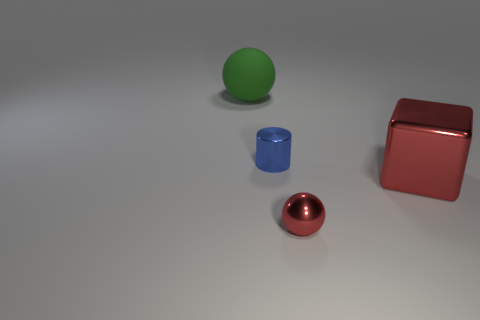Add 2 big red cubes. How many objects exist? 6 Subtract all cylinders. How many objects are left? 3 Add 1 big red metal cubes. How many big red metal cubes are left? 2 Add 4 tiny red matte things. How many tiny red matte things exist? 4 Subtract 0 green cylinders. How many objects are left? 4 Subtract 1 blocks. How many blocks are left? 0 Subtract all cyan spheres. Subtract all blue cylinders. How many spheres are left? 2 Subtract all blue metallic cylinders. Subtract all cyan metal spheres. How many objects are left? 3 